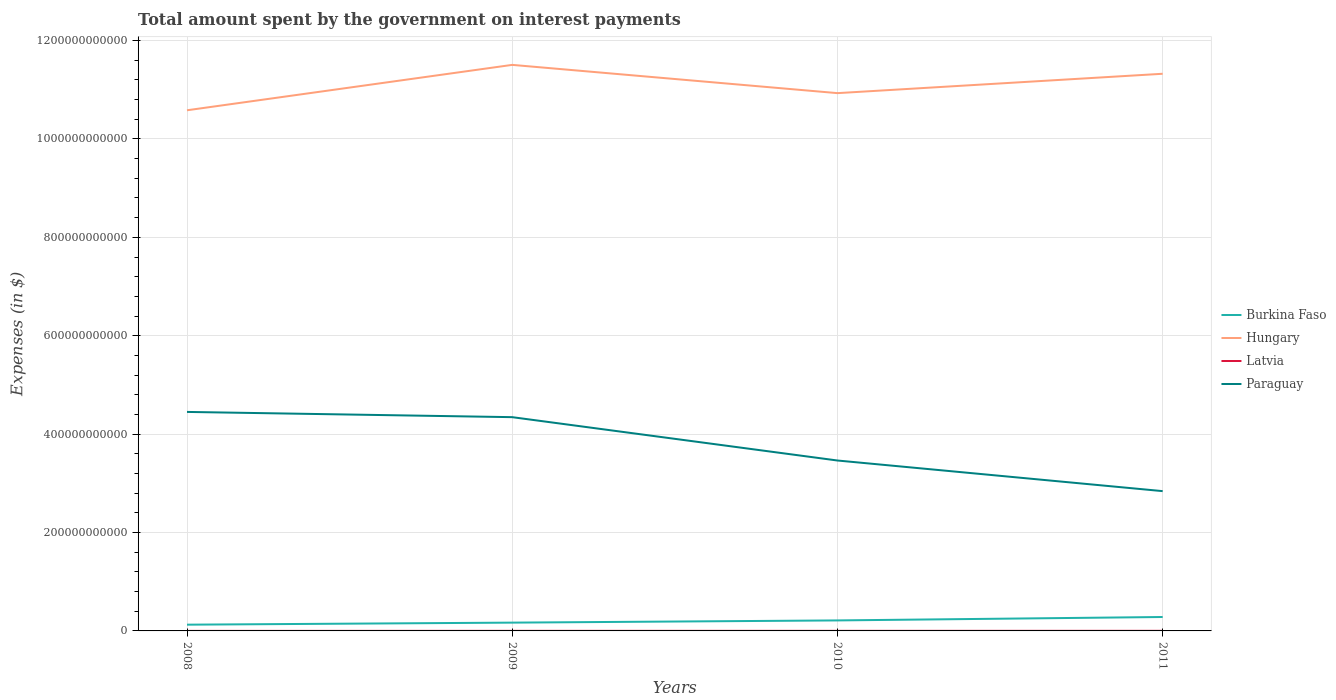How many different coloured lines are there?
Offer a terse response. 4. Does the line corresponding to Paraguay intersect with the line corresponding to Hungary?
Offer a very short reply. No. Is the number of lines equal to the number of legend labels?
Your answer should be very brief. Yes. Across all years, what is the maximum amount spent on interest payments by the government in Paraguay?
Keep it short and to the point. 2.84e+11. In which year was the amount spent on interest payments by the government in Hungary maximum?
Ensure brevity in your answer.  2008. What is the total amount spent on interest payments by the government in Latvia in the graph?
Your answer should be very brief. -8.50e+07. What is the difference between the highest and the second highest amount spent on interest payments by the government in Paraguay?
Offer a terse response. 1.61e+11. How many lines are there?
Provide a succinct answer. 4. How many years are there in the graph?
Provide a short and direct response. 4. What is the difference between two consecutive major ticks on the Y-axis?
Offer a very short reply. 2.00e+11. Are the values on the major ticks of Y-axis written in scientific E-notation?
Your response must be concise. No. Does the graph contain any zero values?
Your answer should be very brief. No. Where does the legend appear in the graph?
Offer a terse response. Center right. How many legend labels are there?
Provide a succinct answer. 4. How are the legend labels stacked?
Ensure brevity in your answer.  Vertical. What is the title of the graph?
Keep it short and to the point. Total amount spent by the government on interest payments. What is the label or title of the Y-axis?
Ensure brevity in your answer.  Expenses (in $). What is the Expenses (in $) in Burkina Faso in 2008?
Your response must be concise. 1.27e+1. What is the Expenses (in $) of Hungary in 2008?
Your answer should be very brief. 1.06e+12. What is the Expenses (in $) of Latvia in 2008?
Your answer should be very brief. 5.90e+07. What is the Expenses (in $) of Paraguay in 2008?
Provide a succinct answer. 4.45e+11. What is the Expenses (in $) of Burkina Faso in 2009?
Make the answer very short. 1.69e+1. What is the Expenses (in $) in Hungary in 2009?
Offer a very short reply. 1.15e+12. What is the Expenses (in $) of Latvia in 2009?
Provide a succinct answer. 1.44e+08. What is the Expenses (in $) of Paraguay in 2009?
Provide a succinct answer. 4.35e+11. What is the Expenses (in $) of Burkina Faso in 2010?
Give a very brief answer. 2.14e+1. What is the Expenses (in $) in Hungary in 2010?
Your response must be concise. 1.09e+12. What is the Expenses (in $) in Latvia in 2010?
Give a very brief answer. 1.70e+08. What is the Expenses (in $) of Paraguay in 2010?
Give a very brief answer. 3.46e+11. What is the Expenses (in $) in Burkina Faso in 2011?
Your answer should be very brief. 2.83e+1. What is the Expenses (in $) in Hungary in 2011?
Give a very brief answer. 1.13e+12. What is the Expenses (in $) of Latvia in 2011?
Your response must be concise. 1.91e+08. What is the Expenses (in $) in Paraguay in 2011?
Your answer should be very brief. 2.84e+11. Across all years, what is the maximum Expenses (in $) in Burkina Faso?
Make the answer very short. 2.83e+1. Across all years, what is the maximum Expenses (in $) of Hungary?
Your answer should be very brief. 1.15e+12. Across all years, what is the maximum Expenses (in $) in Latvia?
Provide a succinct answer. 1.91e+08. Across all years, what is the maximum Expenses (in $) in Paraguay?
Offer a very short reply. 4.45e+11. Across all years, what is the minimum Expenses (in $) in Burkina Faso?
Your answer should be compact. 1.27e+1. Across all years, what is the minimum Expenses (in $) of Hungary?
Keep it short and to the point. 1.06e+12. Across all years, what is the minimum Expenses (in $) in Latvia?
Make the answer very short. 5.90e+07. Across all years, what is the minimum Expenses (in $) of Paraguay?
Offer a terse response. 2.84e+11. What is the total Expenses (in $) in Burkina Faso in the graph?
Your response must be concise. 7.92e+1. What is the total Expenses (in $) in Hungary in the graph?
Your answer should be very brief. 4.43e+12. What is the total Expenses (in $) in Latvia in the graph?
Provide a short and direct response. 5.64e+08. What is the total Expenses (in $) in Paraguay in the graph?
Keep it short and to the point. 1.51e+12. What is the difference between the Expenses (in $) of Burkina Faso in 2008 and that in 2009?
Your response must be concise. -4.18e+09. What is the difference between the Expenses (in $) of Hungary in 2008 and that in 2009?
Make the answer very short. -9.23e+1. What is the difference between the Expenses (in $) in Latvia in 2008 and that in 2009?
Your answer should be compact. -8.50e+07. What is the difference between the Expenses (in $) of Paraguay in 2008 and that in 2009?
Offer a very short reply. 1.06e+1. What is the difference between the Expenses (in $) of Burkina Faso in 2008 and that in 2010?
Ensure brevity in your answer.  -8.66e+09. What is the difference between the Expenses (in $) in Hungary in 2008 and that in 2010?
Your response must be concise. -3.49e+1. What is the difference between the Expenses (in $) of Latvia in 2008 and that in 2010?
Keep it short and to the point. -1.11e+08. What is the difference between the Expenses (in $) of Paraguay in 2008 and that in 2010?
Provide a short and direct response. 9.87e+1. What is the difference between the Expenses (in $) of Burkina Faso in 2008 and that in 2011?
Keep it short and to the point. -1.56e+1. What is the difference between the Expenses (in $) in Hungary in 2008 and that in 2011?
Give a very brief answer. -7.42e+1. What is the difference between the Expenses (in $) of Latvia in 2008 and that in 2011?
Ensure brevity in your answer.  -1.32e+08. What is the difference between the Expenses (in $) of Paraguay in 2008 and that in 2011?
Your response must be concise. 1.61e+11. What is the difference between the Expenses (in $) in Burkina Faso in 2009 and that in 2010?
Provide a succinct answer. -4.48e+09. What is the difference between the Expenses (in $) in Hungary in 2009 and that in 2010?
Offer a very short reply. 5.74e+1. What is the difference between the Expenses (in $) in Latvia in 2009 and that in 2010?
Provide a short and direct response. -2.62e+07. What is the difference between the Expenses (in $) of Paraguay in 2009 and that in 2010?
Make the answer very short. 8.81e+1. What is the difference between the Expenses (in $) of Burkina Faso in 2009 and that in 2011?
Provide a short and direct response. -1.14e+1. What is the difference between the Expenses (in $) in Hungary in 2009 and that in 2011?
Provide a short and direct response. 1.81e+1. What is the difference between the Expenses (in $) of Latvia in 2009 and that in 2011?
Ensure brevity in your answer.  -4.69e+07. What is the difference between the Expenses (in $) in Paraguay in 2009 and that in 2011?
Provide a succinct answer. 1.50e+11. What is the difference between the Expenses (in $) in Burkina Faso in 2010 and that in 2011?
Your response must be concise. -6.94e+09. What is the difference between the Expenses (in $) in Hungary in 2010 and that in 2011?
Ensure brevity in your answer.  -3.94e+1. What is the difference between the Expenses (in $) of Latvia in 2010 and that in 2011?
Offer a terse response. -2.07e+07. What is the difference between the Expenses (in $) of Paraguay in 2010 and that in 2011?
Your answer should be compact. 6.23e+1. What is the difference between the Expenses (in $) of Burkina Faso in 2008 and the Expenses (in $) of Hungary in 2009?
Ensure brevity in your answer.  -1.14e+12. What is the difference between the Expenses (in $) of Burkina Faso in 2008 and the Expenses (in $) of Latvia in 2009?
Your answer should be compact. 1.25e+1. What is the difference between the Expenses (in $) in Burkina Faso in 2008 and the Expenses (in $) in Paraguay in 2009?
Keep it short and to the point. -4.22e+11. What is the difference between the Expenses (in $) in Hungary in 2008 and the Expenses (in $) in Latvia in 2009?
Offer a terse response. 1.06e+12. What is the difference between the Expenses (in $) in Hungary in 2008 and the Expenses (in $) in Paraguay in 2009?
Your answer should be very brief. 6.24e+11. What is the difference between the Expenses (in $) of Latvia in 2008 and the Expenses (in $) of Paraguay in 2009?
Your answer should be very brief. -4.34e+11. What is the difference between the Expenses (in $) in Burkina Faso in 2008 and the Expenses (in $) in Hungary in 2010?
Your answer should be very brief. -1.08e+12. What is the difference between the Expenses (in $) in Burkina Faso in 2008 and the Expenses (in $) in Latvia in 2010?
Keep it short and to the point. 1.25e+1. What is the difference between the Expenses (in $) in Burkina Faso in 2008 and the Expenses (in $) in Paraguay in 2010?
Offer a very short reply. -3.34e+11. What is the difference between the Expenses (in $) in Hungary in 2008 and the Expenses (in $) in Latvia in 2010?
Make the answer very short. 1.06e+12. What is the difference between the Expenses (in $) in Hungary in 2008 and the Expenses (in $) in Paraguay in 2010?
Your answer should be very brief. 7.12e+11. What is the difference between the Expenses (in $) of Latvia in 2008 and the Expenses (in $) of Paraguay in 2010?
Give a very brief answer. -3.46e+11. What is the difference between the Expenses (in $) of Burkina Faso in 2008 and the Expenses (in $) of Hungary in 2011?
Make the answer very short. -1.12e+12. What is the difference between the Expenses (in $) of Burkina Faso in 2008 and the Expenses (in $) of Latvia in 2011?
Provide a succinct answer. 1.25e+1. What is the difference between the Expenses (in $) of Burkina Faso in 2008 and the Expenses (in $) of Paraguay in 2011?
Make the answer very short. -2.71e+11. What is the difference between the Expenses (in $) of Hungary in 2008 and the Expenses (in $) of Latvia in 2011?
Provide a short and direct response. 1.06e+12. What is the difference between the Expenses (in $) in Hungary in 2008 and the Expenses (in $) in Paraguay in 2011?
Your answer should be compact. 7.74e+11. What is the difference between the Expenses (in $) in Latvia in 2008 and the Expenses (in $) in Paraguay in 2011?
Your answer should be compact. -2.84e+11. What is the difference between the Expenses (in $) in Burkina Faso in 2009 and the Expenses (in $) in Hungary in 2010?
Offer a very short reply. -1.08e+12. What is the difference between the Expenses (in $) of Burkina Faso in 2009 and the Expenses (in $) of Latvia in 2010?
Your response must be concise. 1.67e+1. What is the difference between the Expenses (in $) of Burkina Faso in 2009 and the Expenses (in $) of Paraguay in 2010?
Make the answer very short. -3.30e+11. What is the difference between the Expenses (in $) of Hungary in 2009 and the Expenses (in $) of Latvia in 2010?
Keep it short and to the point. 1.15e+12. What is the difference between the Expenses (in $) of Hungary in 2009 and the Expenses (in $) of Paraguay in 2010?
Offer a terse response. 8.04e+11. What is the difference between the Expenses (in $) of Latvia in 2009 and the Expenses (in $) of Paraguay in 2010?
Your response must be concise. -3.46e+11. What is the difference between the Expenses (in $) in Burkina Faso in 2009 and the Expenses (in $) in Hungary in 2011?
Give a very brief answer. -1.12e+12. What is the difference between the Expenses (in $) in Burkina Faso in 2009 and the Expenses (in $) in Latvia in 2011?
Make the answer very short. 1.67e+1. What is the difference between the Expenses (in $) in Burkina Faso in 2009 and the Expenses (in $) in Paraguay in 2011?
Your answer should be very brief. -2.67e+11. What is the difference between the Expenses (in $) of Hungary in 2009 and the Expenses (in $) of Latvia in 2011?
Ensure brevity in your answer.  1.15e+12. What is the difference between the Expenses (in $) in Hungary in 2009 and the Expenses (in $) in Paraguay in 2011?
Ensure brevity in your answer.  8.66e+11. What is the difference between the Expenses (in $) in Latvia in 2009 and the Expenses (in $) in Paraguay in 2011?
Your answer should be very brief. -2.84e+11. What is the difference between the Expenses (in $) in Burkina Faso in 2010 and the Expenses (in $) in Hungary in 2011?
Provide a short and direct response. -1.11e+12. What is the difference between the Expenses (in $) of Burkina Faso in 2010 and the Expenses (in $) of Latvia in 2011?
Offer a very short reply. 2.12e+1. What is the difference between the Expenses (in $) in Burkina Faso in 2010 and the Expenses (in $) in Paraguay in 2011?
Your response must be concise. -2.63e+11. What is the difference between the Expenses (in $) of Hungary in 2010 and the Expenses (in $) of Latvia in 2011?
Your answer should be very brief. 1.09e+12. What is the difference between the Expenses (in $) of Hungary in 2010 and the Expenses (in $) of Paraguay in 2011?
Your answer should be compact. 8.09e+11. What is the difference between the Expenses (in $) of Latvia in 2010 and the Expenses (in $) of Paraguay in 2011?
Offer a terse response. -2.84e+11. What is the average Expenses (in $) of Burkina Faso per year?
Provide a short and direct response. 1.98e+1. What is the average Expenses (in $) of Hungary per year?
Offer a terse response. 1.11e+12. What is the average Expenses (in $) in Latvia per year?
Your response must be concise. 1.41e+08. What is the average Expenses (in $) of Paraguay per year?
Your answer should be compact. 3.78e+11. In the year 2008, what is the difference between the Expenses (in $) of Burkina Faso and Expenses (in $) of Hungary?
Offer a very short reply. -1.05e+12. In the year 2008, what is the difference between the Expenses (in $) in Burkina Faso and Expenses (in $) in Latvia?
Offer a terse response. 1.26e+1. In the year 2008, what is the difference between the Expenses (in $) of Burkina Faso and Expenses (in $) of Paraguay?
Provide a succinct answer. -4.32e+11. In the year 2008, what is the difference between the Expenses (in $) in Hungary and Expenses (in $) in Latvia?
Provide a succinct answer. 1.06e+12. In the year 2008, what is the difference between the Expenses (in $) of Hungary and Expenses (in $) of Paraguay?
Keep it short and to the point. 6.13e+11. In the year 2008, what is the difference between the Expenses (in $) in Latvia and Expenses (in $) in Paraguay?
Offer a terse response. -4.45e+11. In the year 2009, what is the difference between the Expenses (in $) in Burkina Faso and Expenses (in $) in Hungary?
Keep it short and to the point. -1.13e+12. In the year 2009, what is the difference between the Expenses (in $) of Burkina Faso and Expenses (in $) of Latvia?
Your answer should be compact. 1.67e+1. In the year 2009, what is the difference between the Expenses (in $) of Burkina Faso and Expenses (in $) of Paraguay?
Offer a very short reply. -4.18e+11. In the year 2009, what is the difference between the Expenses (in $) in Hungary and Expenses (in $) in Latvia?
Make the answer very short. 1.15e+12. In the year 2009, what is the difference between the Expenses (in $) of Hungary and Expenses (in $) of Paraguay?
Provide a succinct answer. 7.16e+11. In the year 2009, what is the difference between the Expenses (in $) in Latvia and Expenses (in $) in Paraguay?
Ensure brevity in your answer.  -4.34e+11. In the year 2010, what is the difference between the Expenses (in $) of Burkina Faso and Expenses (in $) of Hungary?
Provide a short and direct response. -1.07e+12. In the year 2010, what is the difference between the Expenses (in $) in Burkina Faso and Expenses (in $) in Latvia?
Offer a terse response. 2.12e+1. In the year 2010, what is the difference between the Expenses (in $) in Burkina Faso and Expenses (in $) in Paraguay?
Your answer should be very brief. -3.25e+11. In the year 2010, what is the difference between the Expenses (in $) in Hungary and Expenses (in $) in Latvia?
Make the answer very short. 1.09e+12. In the year 2010, what is the difference between the Expenses (in $) of Hungary and Expenses (in $) of Paraguay?
Ensure brevity in your answer.  7.47e+11. In the year 2010, what is the difference between the Expenses (in $) of Latvia and Expenses (in $) of Paraguay?
Offer a very short reply. -3.46e+11. In the year 2011, what is the difference between the Expenses (in $) of Burkina Faso and Expenses (in $) of Hungary?
Your answer should be compact. -1.10e+12. In the year 2011, what is the difference between the Expenses (in $) of Burkina Faso and Expenses (in $) of Latvia?
Make the answer very short. 2.81e+1. In the year 2011, what is the difference between the Expenses (in $) of Burkina Faso and Expenses (in $) of Paraguay?
Ensure brevity in your answer.  -2.56e+11. In the year 2011, what is the difference between the Expenses (in $) of Hungary and Expenses (in $) of Latvia?
Your response must be concise. 1.13e+12. In the year 2011, what is the difference between the Expenses (in $) in Hungary and Expenses (in $) in Paraguay?
Your answer should be compact. 8.48e+11. In the year 2011, what is the difference between the Expenses (in $) in Latvia and Expenses (in $) in Paraguay?
Offer a terse response. -2.84e+11. What is the ratio of the Expenses (in $) of Burkina Faso in 2008 to that in 2009?
Provide a short and direct response. 0.75. What is the ratio of the Expenses (in $) in Hungary in 2008 to that in 2009?
Offer a terse response. 0.92. What is the ratio of the Expenses (in $) in Latvia in 2008 to that in 2009?
Ensure brevity in your answer.  0.41. What is the ratio of the Expenses (in $) of Paraguay in 2008 to that in 2009?
Keep it short and to the point. 1.02. What is the ratio of the Expenses (in $) in Burkina Faso in 2008 to that in 2010?
Ensure brevity in your answer.  0.59. What is the ratio of the Expenses (in $) in Hungary in 2008 to that in 2010?
Provide a short and direct response. 0.97. What is the ratio of the Expenses (in $) in Latvia in 2008 to that in 2010?
Offer a terse response. 0.35. What is the ratio of the Expenses (in $) in Paraguay in 2008 to that in 2010?
Provide a short and direct response. 1.29. What is the ratio of the Expenses (in $) of Burkina Faso in 2008 to that in 2011?
Ensure brevity in your answer.  0.45. What is the ratio of the Expenses (in $) in Hungary in 2008 to that in 2011?
Provide a succinct answer. 0.93. What is the ratio of the Expenses (in $) of Latvia in 2008 to that in 2011?
Your response must be concise. 0.31. What is the ratio of the Expenses (in $) of Paraguay in 2008 to that in 2011?
Provide a succinct answer. 1.57. What is the ratio of the Expenses (in $) of Burkina Faso in 2009 to that in 2010?
Make the answer very short. 0.79. What is the ratio of the Expenses (in $) of Hungary in 2009 to that in 2010?
Make the answer very short. 1.05. What is the ratio of the Expenses (in $) of Latvia in 2009 to that in 2010?
Offer a terse response. 0.85. What is the ratio of the Expenses (in $) of Paraguay in 2009 to that in 2010?
Provide a succinct answer. 1.25. What is the ratio of the Expenses (in $) in Burkina Faso in 2009 to that in 2011?
Provide a succinct answer. 0.6. What is the ratio of the Expenses (in $) in Latvia in 2009 to that in 2011?
Ensure brevity in your answer.  0.75. What is the ratio of the Expenses (in $) in Paraguay in 2009 to that in 2011?
Provide a succinct answer. 1.53. What is the ratio of the Expenses (in $) of Burkina Faso in 2010 to that in 2011?
Provide a succinct answer. 0.75. What is the ratio of the Expenses (in $) in Hungary in 2010 to that in 2011?
Keep it short and to the point. 0.97. What is the ratio of the Expenses (in $) of Latvia in 2010 to that in 2011?
Your answer should be very brief. 0.89. What is the ratio of the Expenses (in $) in Paraguay in 2010 to that in 2011?
Your answer should be very brief. 1.22. What is the difference between the highest and the second highest Expenses (in $) in Burkina Faso?
Ensure brevity in your answer.  6.94e+09. What is the difference between the highest and the second highest Expenses (in $) in Hungary?
Provide a short and direct response. 1.81e+1. What is the difference between the highest and the second highest Expenses (in $) in Latvia?
Offer a terse response. 2.07e+07. What is the difference between the highest and the second highest Expenses (in $) of Paraguay?
Your answer should be very brief. 1.06e+1. What is the difference between the highest and the lowest Expenses (in $) of Burkina Faso?
Make the answer very short. 1.56e+1. What is the difference between the highest and the lowest Expenses (in $) of Hungary?
Make the answer very short. 9.23e+1. What is the difference between the highest and the lowest Expenses (in $) in Latvia?
Provide a succinct answer. 1.32e+08. What is the difference between the highest and the lowest Expenses (in $) in Paraguay?
Your answer should be very brief. 1.61e+11. 